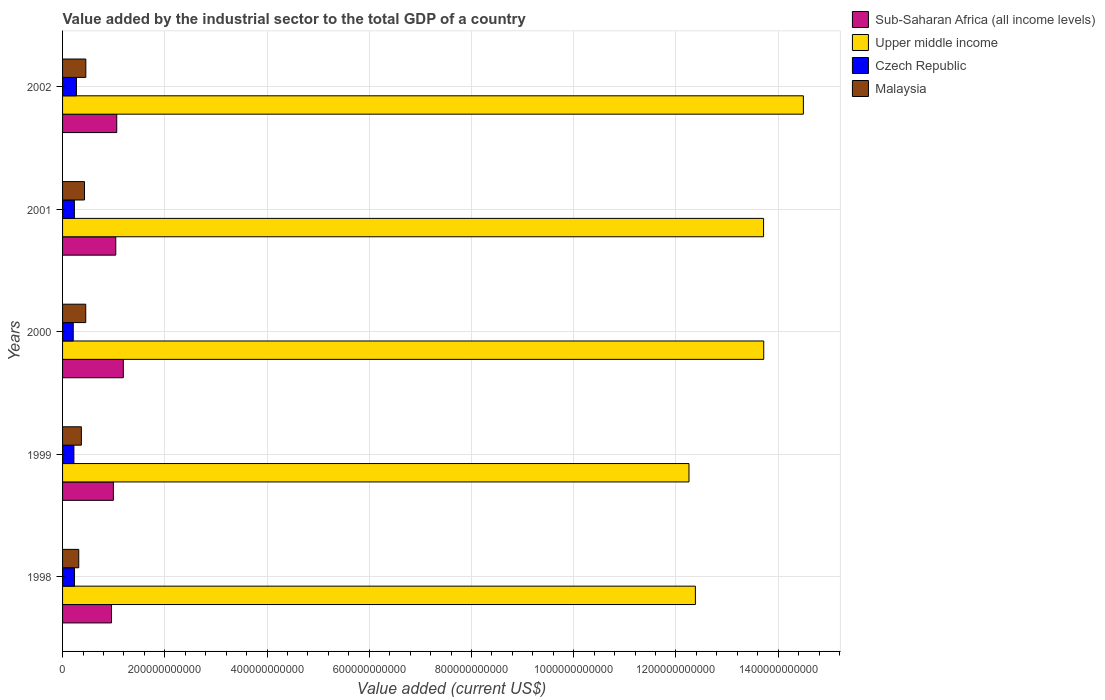Are the number of bars on each tick of the Y-axis equal?
Offer a terse response. Yes. How many bars are there on the 4th tick from the top?
Offer a very short reply. 4. How many bars are there on the 4th tick from the bottom?
Give a very brief answer. 4. What is the label of the 4th group of bars from the top?
Your answer should be very brief. 1999. What is the value added by the industrial sector to the total GDP in Czech Republic in 2002?
Keep it short and to the point. 2.72e+1. Across all years, what is the maximum value added by the industrial sector to the total GDP in Upper middle income?
Your response must be concise. 1.45e+12. Across all years, what is the minimum value added by the industrial sector to the total GDP in Czech Republic?
Your response must be concise. 2.09e+1. In which year was the value added by the industrial sector to the total GDP in Malaysia maximum?
Give a very brief answer. 2002. In which year was the value added by the industrial sector to the total GDP in Malaysia minimum?
Your response must be concise. 1998. What is the total value added by the industrial sector to the total GDP in Czech Republic in the graph?
Provide a short and direct response. 1.17e+11. What is the difference between the value added by the industrial sector to the total GDP in Czech Republic in 1998 and that in 2001?
Provide a short and direct response. 2.36e+08. What is the difference between the value added by the industrial sector to the total GDP in Upper middle income in 1999 and the value added by the industrial sector to the total GDP in Sub-Saharan Africa (all income levels) in 2002?
Give a very brief answer. 1.12e+12. What is the average value added by the industrial sector to the total GDP in Czech Republic per year?
Make the answer very short. 2.34e+1. In the year 2000, what is the difference between the value added by the industrial sector to the total GDP in Malaysia and value added by the industrial sector to the total GDP in Upper middle income?
Offer a terse response. -1.33e+12. What is the ratio of the value added by the industrial sector to the total GDP in Sub-Saharan Africa (all income levels) in 1998 to that in 2002?
Ensure brevity in your answer.  0.9. What is the difference between the highest and the second highest value added by the industrial sector to the total GDP in Upper middle income?
Provide a succinct answer. 7.75e+1. What is the difference between the highest and the lowest value added by the industrial sector to the total GDP in Malaysia?
Provide a short and direct response. 1.38e+1. Is it the case that in every year, the sum of the value added by the industrial sector to the total GDP in Upper middle income and value added by the industrial sector to the total GDP in Malaysia is greater than the sum of value added by the industrial sector to the total GDP in Sub-Saharan Africa (all income levels) and value added by the industrial sector to the total GDP in Czech Republic?
Offer a very short reply. No. What does the 1st bar from the top in 2002 represents?
Your answer should be compact. Malaysia. What does the 1st bar from the bottom in 1999 represents?
Give a very brief answer. Sub-Saharan Africa (all income levels). How many bars are there?
Your answer should be compact. 20. What is the difference between two consecutive major ticks on the X-axis?
Keep it short and to the point. 2.00e+11. Are the values on the major ticks of X-axis written in scientific E-notation?
Your response must be concise. No. Does the graph contain any zero values?
Ensure brevity in your answer.  No. Does the graph contain grids?
Your answer should be compact. Yes. Where does the legend appear in the graph?
Give a very brief answer. Top right. How many legend labels are there?
Give a very brief answer. 4. How are the legend labels stacked?
Provide a short and direct response. Vertical. What is the title of the graph?
Give a very brief answer. Value added by the industrial sector to the total GDP of a country. What is the label or title of the X-axis?
Keep it short and to the point. Value added (current US$). What is the label or title of the Y-axis?
Provide a short and direct response. Years. What is the Value added (current US$) in Sub-Saharan Africa (all income levels) in 1998?
Provide a succinct answer. 9.58e+1. What is the Value added (current US$) of Upper middle income in 1998?
Your answer should be very brief. 1.24e+12. What is the Value added (current US$) of Czech Republic in 1998?
Provide a succinct answer. 2.34e+1. What is the Value added (current US$) of Malaysia in 1998?
Ensure brevity in your answer.  3.17e+1. What is the Value added (current US$) of Sub-Saharan Africa (all income levels) in 1999?
Offer a very short reply. 9.94e+1. What is the Value added (current US$) of Upper middle income in 1999?
Offer a very short reply. 1.23e+12. What is the Value added (current US$) in Czech Republic in 1999?
Offer a very short reply. 2.21e+1. What is the Value added (current US$) in Malaysia in 1999?
Make the answer very short. 3.68e+1. What is the Value added (current US$) in Sub-Saharan Africa (all income levels) in 2000?
Provide a succinct answer. 1.19e+11. What is the Value added (current US$) of Upper middle income in 2000?
Your answer should be compact. 1.37e+12. What is the Value added (current US$) in Czech Republic in 2000?
Your response must be concise. 2.09e+1. What is the Value added (current US$) of Malaysia in 2000?
Your answer should be compact. 4.53e+1. What is the Value added (current US$) of Sub-Saharan Africa (all income levels) in 2001?
Offer a terse response. 1.04e+11. What is the Value added (current US$) of Upper middle income in 2001?
Your answer should be compact. 1.37e+12. What is the Value added (current US$) of Czech Republic in 2001?
Provide a short and direct response. 2.31e+1. What is the Value added (current US$) in Malaysia in 2001?
Provide a succinct answer. 4.29e+1. What is the Value added (current US$) of Sub-Saharan Africa (all income levels) in 2002?
Provide a succinct answer. 1.06e+11. What is the Value added (current US$) of Upper middle income in 2002?
Offer a very short reply. 1.45e+12. What is the Value added (current US$) in Czech Republic in 2002?
Give a very brief answer. 2.72e+1. What is the Value added (current US$) of Malaysia in 2002?
Offer a terse response. 4.55e+1. Across all years, what is the maximum Value added (current US$) of Sub-Saharan Africa (all income levels)?
Your answer should be compact. 1.19e+11. Across all years, what is the maximum Value added (current US$) in Upper middle income?
Your answer should be compact. 1.45e+12. Across all years, what is the maximum Value added (current US$) of Czech Republic?
Your answer should be compact. 2.72e+1. Across all years, what is the maximum Value added (current US$) of Malaysia?
Offer a very short reply. 4.55e+1. Across all years, what is the minimum Value added (current US$) of Sub-Saharan Africa (all income levels)?
Your response must be concise. 9.58e+1. Across all years, what is the minimum Value added (current US$) in Upper middle income?
Offer a terse response. 1.23e+12. Across all years, what is the minimum Value added (current US$) of Czech Republic?
Your answer should be very brief. 2.09e+1. Across all years, what is the minimum Value added (current US$) of Malaysia?
Offer a terse response. 3.17e+1. What is the total Value added (current US$) of Sub-Saharan Africa (all income levels) in the graph?
Make the answer very short. 5.24e+11. What is the total Value added (current US$) of Upper middle income in the graph?
Keep it short and to the point. 6.66e+12. What is the total Value added (current US$) of Czech Republic in the graph?
Your answer should be compact. 1.17e+11. What is the total Value added (current US$) in Malaysia in the graph?
Provide a succinct answer. 2.02e+11. What is the difference between the Value added (current US$) of Sub-Saharan Africa (all income levels) in 1998 and that in 1999?
Your answer should be very brief. -3.67e+09. What is the difference between the Value added (current US$) in Upper middle income in 1998 and that in 1999?
Your response must be concise. 1.25e+1. What is the difference between the Value added (current US$) of Czech Republic in 1998 and that in 1999?
Keep it short and to the point. 1.23e+09. What is the difference between the Value added (current US$) in Malaysia in 1998 and that in 1999?
Make the answer very short. -5.11e+09. What is the difference between the Value added (current US$) in Sub-Saharan Africa (all income levels) in 1998 and that in 2000?
Your answer should be very brief. -2.31e+1. What is the difference between the Value added (current US$) in Upper middle income in 1998 and that in 2000?
Your response must be concise. -1.34e+11. What is the difference between the Value added (current US$) of Czech Republic in 1998 and that in 2000?
Keep it short and to the point. 2.49e+09. What is the difference between the Value added (current US$) of Malaysia in 1998 and that in 2000?
Ensure brevity in your answer.  -1.37e+1. What is the difference between the Value added (current US$) in Sub-Saharan Africa (all income levels) in 1998 and that in 2001?
Make the answer very short. -8.33e+09. What is the difference between the Value added (current US$) in Upper middle income in 1998 and that in 2001?
Provide a succinct answer. -1.33e+11. What is the difference between the Value added (current US$) in Czech Republic in 1998 and that in 2001?
Your answer should be compact. 2.36e+08. What is the difference between the Value added (current US$) in Malaysia in 1998 and that in 2001?
Keep it short and to the point. -1.12e+1. What is the difference between the Value added (current US$) of Sub-Saharan Africa (all income levels) in 1998 and that in 2002?
Your answer should be compact. -1.02e+1. What is the difference between the Value added (current US$) of Upper middle income in 1998 and that in 2002?
Offer a terse response. -2.11e+11. What is the difference between the Value added (current US$) in Czech Republic in 1998 and that in 2002?
Ensure brevity in your answer.  -3.86e+09. What is the difference between the Value added (current US$) of Malaysia in 1998 and that in 2002?
Your answer should be very brief. -1.38e+1. What is the difference between the Value added (current US$) in Sub-Saharan Africa (all income levels) in 1999 and that in 2000?
Make the answer very short. -1.94e+1. What is the difference between the Value added (current US$) of Upper middle income in 1999 and that in 2000?
Offer a very short reply. -1.46e+11. What is the difference between the Value added (current US$) in Czech Republic in 1999 and that in 2000?
Your answer should be compact. 1.26e+09. What is the difference between the Value added (current US$) in Malaysia in 1999 and that in 2000?
Provide a short and direct response. -8.55e+09. What is the difference between the Value added (current US$) of Sub-Saharan Africa (all income levels) in 1999 and that in 2001?
Keep it short and to the point. -4.66e+09. What is the difference between the Value added (current US$) of Upper middle income in 1999 and that in 2001?
Your answer should be compact. -1.46e+11. What is the difference between the Value added (current US$) of Czech Republic in 1999 and that in 2001?
Offer a terse response. -9.94e+08. What is the difference between the Value added (current US$) in Malaysia in 1999 and that in 2001?
Ensure brevity in your answer.  -6.10e+09. What is the difference between the Value added (current US$) in Sub-Saharan Africa (all income levels) in 1999 and that in 2002?
Ensure brevity in your answer.  -6.55e+09. What is the difference between the Value added (current US$) of Upper middle income in 1999 and that in 2002?
Provide a short and direct response. -2.24e+11. What is the difference between the Value added (current US$) of Czech Republic in 1999 and that in 2002?
Provide a short and direct response. -5.09e+09. What is the difference between the Value added (current US$) in Malaysia in 1999 and that in 2002?
Make the answer very short. -8.72e+09. What is the difference between the Value added (current US$) in Sub-Saharan Africa (all income levels) in 2000 and that in 2001?
Offer a very short reply. 1.48e+1. What is the difference between the Value added (current US$) in Upper middle income in 2000 and that in 2001?
Give a very brief answer. 3.16e+08. What is the difference between the Value added (current US$) in Czech Republic in 2000 and that in 2001?
Provide a succinct answer. -2.26e+09. What is the difference between the Value added (current US$) of Malaysia in 2000 and that in 2001?
Ensure brevity in your answer.  2.45e+09. What is the difference between the Value added (current US$) of Sub-Saharan Africa (all income levels) in 2000 and that in 2002?
Offer a terse response. 1.29e+1. What is the difference between the Value added (current US$) in Upper middle income in 2000 and that in 2002?
Make the answer very short. -7.75e+1. What is the difference between the Value added (current US$) in Czech Republic in 2000 and that in 2002?
Your answer should be very brief. -6.35e+09. What is the difference between the Value added (current US$) of Malaysia in 2000 and that in 2002?
Your answer should be compact. -1.78e+08. What is the difference between the Value added (current US$) of Sub-Saharan Africa (all income levels) in 2001 and that in 2002?
Your response must be concise. -1.89e+09. What is the difference between the Value added (current US$) of Upper middle income in 2001 and that in 2002?
Your response must be concise. -7.79e+1. What is the difference between the Value added (current US$) in Czech Republic in 2001 and that in 2002?
Make the answer very short. -4.10e+09. What is the difference between the Value added (current US$) of Malaysia in 2001 and that in 2002?
Your answer should be very brief. -2.63e+09. What is the difference between the Value added (current US$) of Sub-Saharan Africa (all income levels) in 1998 and the Value added (current US$) of Upper middle income in 1999?
Your answer should be very brief. -1.13e+12. What is the difference between the Value added (current US$) of Sub-Saharan Africa (all income levels) in 1998 and the Value added (current US$) of Czech Republic in 1999?
Provide a succinct answer. 7.36e+1. What is the difference between the Value added (current US$) in Sub-Saharan Africa (all income levels) in 1998 and the Value added (current US$) in Malaysia in 1999?
Offer a terse response. 5.90e+1. What is the difference between the Value added (current US$) in Upper middle income in 1998 and the Value added (current US$) in Czech Republic in 1999?
Give a very brief answer. 1.22e+12. What is the difference between the Value added (current US$) of Upper middle income in 1998 and the Value added (current US$) of Malaysia in 1999?
Provide a succinct answer. 1.20e+12. What is the difference between the Value added (current US$) in Czech Republic in 1998 and the Value added (current US$) in Malaysia in 1999?
Your response must be concise. -1.34e+1. What is the difference between the Value added (current US$) of Sub-Saharan Africa (all income levels) in 1998 and the Value added (current US$) of Upper middle income in 2000?
Your answer should be very brief. -1.28e+12. What is the difference between the Value added (current US$) in Sub-Saharan Africa (all income levels) in 1998 and the Value added (current US$) in Czech Republic in 2000?
Your answer should be compact. 7.49e+1. What is the difference between the Value added (current US$) in Sub-Saharan Africa (all income levels) in 1998 and the Value added (current US$) in Malaysia in 2000?
Make the answer very short. 5.04e+1. What is the difference between the Value added (current US$) in Upper middle income in 1998 and the Value added (current US$) in Czech Republic in 2000?
Provide a succinct answer. 1.22e+12. What is the difference between the Value added (current US$) of Upper middle income in 1998 and the Value added (current US$) of Malaysia in 2000?
Keep it short and to the point. 1.19e+12. What is the difference between the Value added (current US$) of Czech Republic in 1998 and the Value added (current US$) of Malaysia in 2000?
Make the answer very short. -2.19e+1. What is the difference between the Value added (current US$) of Sub-Saharan Africa (all income levels) in 1998 and the Value added (current US$) of Upper middle income in 2001?
Keep it short and to the point. -1.28e+12. What is the difference between the Value added (current US$) of Sub-Saharan Africa (all income levels) in 1998 and the Value added (current US$) of Czech Republic in 2001?
Make the answer very short. 7.26e+1. What is the difference between the Value added (current US$) of Sub-Saharan Africa (all income levels) in 1998 and the Value added (current US$) of Malaysia in 2001?
Provide a short and direct response. 5.29e+1. What is the difference between the Value added (current US$) in Upper middle income in 1998 and the Value added (current US$) in Czech Republic in 2001?
Ensure brevity in your answer.  1.21e+12. What is the difference between the Value added (current US$) in Upper middle income in 1998 and the Value added (current US$) in Malaysia in 2001?
Your answer should be compact. 1.20e+12. What is the difference between the Value added (current US$) in Czech Republic in 1998 and the Value added (current US$) in Malaysia in 2001?
Your response must be concise. -1.95e+1. What is the difference between the Value added (current US$) in Sub-Saharan Africa (all income levels) in 1998 and the Value added (current US$) in Upper middle income in 2002?
Offer a very short reply. -1.35e+12. What is the difference between the Value added (current US$) of Sub-Saharan Africa (all income levels) in 1998 and the Value added (current US$) of Czech Republic in 2002?
Your answer should be very brief. 6.85e+1. What is the difference between the Value added (current US$) in Sub-Saharan Africa (all income levels) in 1998 and the Value added (current US$) in Malaysia in 2002?
Your answer should be very brief. 5.03e+1. What is the difference between the Value added (current US$) in Upper middle income in 1998 and the Value added (current US$) in Czech Republic in 2002?
Your response must be concise. 1.21e+12. What is the difference between the Value added (current US$) of Upper middle income in 1998 and the Value added (current US$) of Malaysia in 2002?
Keep it short and to the point. 1.19e+12. What is the difference between the Value added (current US$) of Czech Republic in 1998 and the Value added (current US$) of Malaysia in 2002?
Your answer should be compact. -2.21e+1. What is the difference between the Value added (current US$) in Sub-Saharan Africa (all income levels) in 1999 and the Value added (current US$) in Upper middle income in 2000?
Your answer should be very brief. -1.27e+12. What is the difference between the Value added (current US$) in Sub-Saharan Africa (all income levels) in 1999 and the Value added (current US$) in Czech Republic in 2000?
Offer a very short reply. 7.85e+1. What is the difference between the Value added (current US$) in Sub-Saharan Africa (all income levels) in 1999 and the Value added (current US$) in Malaysia in 2000?
Ensure brevity in your answer.  5.41e+1. What is the difference between the Value added (current US$) of Upper middle income in 1999 and the Value added (current US$) of Czech Republic in 2000?
Your answer should be very brief. 1.20e+12. What is the difference between the Value added (current US$) of Upper middle income in 1999 and the Value added (current US$) of Malaysia in 2000?
Your response must be concise. 1.18e+12. What is the difference between the Value added (current US$) in Czech Republic in 1999 and the Value added (current US$) in Malaysia in 2000?
Give a very brief answer. -2.32e+1. What is the difference between the Value added (current US$) of Sub-Saharan Africa (all income levels) in 1999 and the Value added (current US$) of Upper middle income in 2001?
Your response must be concise. -1.27e+12. What is the difference between the Value added (current US$) of Sub-Saharan Africa (all income levels) in 1999 and the Value added (current US$) of Czech Republic in 2001?
Your answer should be very brief. 7.63e+1. What is the difference between the Value added (current US$) of Sub-Saharan Africa (all income levels) in 1999 and the Value added (current US$) of Malaysia in 2001?
Keep it short and to the point. 5.66e+1. What is the difference between the Value added (current US$) of Upper middle income in 1999 and the Value added (current US$) of Czech Republic in 2001?
Your response must be concise. 1.20e+12. What is the difference between the Value added (current US$) of Upper middle income in 1999 and the Value added (current US$) of Malaysia in 2001?
Your answer should be compact. 1.18e+12. What is the difference between the Value added (current US$) of Czech Republic in 1999 and the Value added (current US$) of Malaysia in 2001?
Your answer should be very brief. -2.07e+1. What is the difference between the Value added (current US$) of Sub-Saharan Africa (all income levels) in 1999 and the Value added (current US$) of Upper middle income in 2002?
Give a very brief answer. -1.35e+12. What is the difference between the Value added (current US$) in Sub-Saharan Africa (all income levels) in 1999 and the Value added (current US$) in Czech Republic in 2002?
Provide a succinct answer. 7.22e+1. What is the difference between the Value added (current US$) of Sub-Saharan Africa (all income levels) in 1999 and the Value added (current US$) of Malaysia in 2002?
Keep it short and to the point. 5.39e+1. What is the difference between the Value added (current US$) in Upper middle income in 1999 and the Value added (current US$) in Czech Republic in 2002?
Provide a succinct answer. 1.20e+12. What is the difference between the Value added (current US$) in Upper middle income in 1999 and the Value added (current US$) in Malaysia in 2002?
Make the answer very short. 1.18e+12. What is the difference between the Value added (current US$) of Czech Republic in 1999 and the Value added (current US$) of Malaysia in 2002?
Provide a succinct answer. -2.34e+1. What is the difference between the Value added (current US$) in Sub-Saharan Africa (all income levels) in 2000 and the Value added (current US$) in Upper middle income in 2001?
Offer a very short reply. -1.25e+12. What is the difference between the Value added (current US$) of Sub-Saharan Africa (all income levels) in 2000 and the Value added (current US$) of Czech Republic in 2001?
Provide a succinct answer. 9.57e+1. What is the difference between the Value added (current US$) of Sub-Saharan Africa (all income levels) in 2000 and the Value added (current US$) of Malaysia in 2001?
Offer a terse response. 7.60e+1. What is the difference between the Value added (current US$) of Upper middle income in 2000 and the Value added (current US$) of Czech Republic in 2001?
Give a very brief answer. 1.35e+12. What is the difference between the Value added (current US$) in Upper middle income in 2000 and the Value added (current US$) in Malaysia in 2001?
Your answer should be very brief. 1.33e+12. What is the difference between the Value added (current US$) in Czech Republic in 2000 and the Value added (current US$) in Malaysia in 2001?
Offer a terse response. -2.20e+1. What is the difference between the Value added (current US$) in Sub-Saharan Africa (all income levels) in 2000 and the Value added (current US$) in Upper middle income in 2002?
Keep it short and to the point. -1.33e+12. What is the difference between the Value added (current US$) of Sub-Saharan Africa (all income levels) in 2000 and the Value added (current US$) of Czech Republic in 2002?
Your response must be concise. 9.16e+1. What is the difference between the Value added (current US$) in Sub-Saharan Africa (all income levels) in 2000 and the Value added (current US$) in Malaysia in 2002?
Your answer should be very brief. 7.34e+1. What is the difference between the Value added (current US$) in Upper middle income in 2000 and the Value added (current US$) in Czech Republic in 2002?
Your response must be concise. 1.34e+12. What is the difference between the Value added (current US$) of Upper middle income in 2000 and the Value added (current US$) of Malaysia in 2002?
Provide a short and direct response. 1.33e+12. What is the difference between the Value added (current US$) of Czech Republic in 2000 and the Value added (current US$) of Malaysia in 2002?
Your answer should be compact. -2.46e+1. What is the difference between the Value added (current US$) of Sub-Saharan Africa (all income levels) in 2001 and the Value added (current US$) of Upper middle income in 2002?
Make the answer very short. -1.35e+12. What is the difference between the Value added (current US$) in Sub-Saharan Africa (all income levels) in 2001 and the Value added (current US$) in Czech Republic in 2002?
Offer a very short reply. 7.69e+1. What is the difference between the Value added (current US$) in Sub-Saharan Africa (all income levels) in 2001 and the Value added (current US$) in Malaysia in 2002?
Your answer should be compact. 5.86e+1. What is the difference between the Value added (current US$) in Upper middle income in 2001 and the Value added (current US$) in Czech Republic in 2002?
Offer a terse response. 1.34e+12. What is the difference between the Value added (current US$) of Upper middle income in 2001 and the Value added (current US$) of Malaysia in 2002?
Offer a terse response. 1.33e+12. What is the difference between the Value added (current US$) of Czech Republic in 2001 and the Value added (current US$) of Malaysia in 2002?
Your answer should be compact. -2.24e+1. What is the average Value added (current US$) in Sub-Saharan Africa (all income levels) per year?
Ensure brevity in your answer.  1.05e+11. What is the average Value added (current US$) in Upper middle income per year?
Offer a terse response. 1.33e+12. What is the average Value added (current US$) of Czech Republic per year?
Give a very brief answer. 2.34e+1. What is the average Value added (current US$) in Malaysia per year?
Give a very brief answer. 4.04e+1. In the year 1998, what is the difference between the Value added (current US$) in Sub-Saharan Africa (all income levels) and Value added (current US$) in Upper middle income?
Your response must be concise. -1.14e+12. In the year 1998, what is the difference between the Value added (current US$) in Sub-Saharan Africa (all income levels) and Value added (current US$) in Czech Republic?
Keep it short and to the point. 7.24e+1. In the year 1998, what is the difference between the Value added (current US$) of Sub-Saharan Africa (all income levels) and Value added (current US$) of Malaysia?
Make the answer very short. 6.41e+1. In the year 1998, what is the difference between the Value added (current US$) of Upper middle income and Value added (current US$) of Czech Republic?
Offer a terse response. 1.21e+12. In the year 1998, what is the difference between the Value added (current US$) of Upper middle income and Value added (current US$) of Malaysia?
Make the answer very short. 1.21e+12. In the year 1998, what is the difference between the Value added (current US$) in Czech Republic and Value added (current US$) in Malaysia?
Keep it short and to the point. -8.29e+09. In the year 1999, what is the difference between the Value added (current US$) in Sub-Saharan Africa (all income levels) and Value added (current US$) in Upper middle income?
Your answer should be compact. -1.13e+12. In the year 1999, what is the difference between the Value added (current US$) of Sub-Saharan Africa (all income levels) and Value added (current US$) of Czech Republic?
Make the answer very short. 7.73e+1. In the year 1999, what is the difference between the Value added (current US$) in Sub-Saharan Africa (all income levels) and Value added (current US$) in Malaysia?
Your answer should be very brief. 6.27e+1. In the year 1999, what is the difference between the Value added (current US$) in Upper middle income and Value added (current US$) in Czech Republic?
Your answer should be very brief. 1.20e+12. In the year 1999, what is the difference between the Value added (current US$) in Upper middle income and Value added (current US$) in Malaysia?
Give a very brief answer. 1.19e+12. In the year 1999, what is the difference between the Value added (current US$) of Czech Republic and Value added (current US$) of Malaysia?
Keep it short and to the point. -1.46e+1. In the year 2000, what is the difference between the Value added (current US$) of Sub-Saharan Africa (all income levels) and Value added (current US$) of Upper middle income?
Offer a very short reply. -1.25e+12. In the year 2000, what is the difference between the Value added (current US$) of Sub-Saharan Africa (all income levels) and Value added (current US$) of Czech Republic?
Give a very brief answer. 9.80e+1. In the year 2000, what is the difference between the Value added (current US$) of Sub-Saharan Africa (all income levels) and Value added (current US$) of Malaysia?
Your answer should be very brief. 7.35e+1. In the year 2000, what is the difference between the Value added (current US$) of Upper middle income and Value added (current US$) of Czech Republic?
Keep it short and to the point. 1.35e+12. In the year 2000, what is the difference between the Value added (current US$) of Upper middle income and Value added (current US$) of Malaysia?
Offer a very short reply. 1.33e+12. In the year 2000, what is the difference between the Value added (current US$) in Czech Republic and Value added (current US$) in Malaysia?
Your answer should be compact. -2.44e+1. In the year 2001, what is the difference between the Value added (current US$) in Sub-Saharan Africa (all income levels) and Value added (current US$) in Upper middle income?
Offer a terse response. -1.27e+12. In the year 2001, what is the difference between the Value added (current US$) in Sub-Saharan Africa (all income levels) and Value added (current US$) in Czech Republic?
Give a very brief answer. 8.09e+1. In the year 2001, what is the difference between the Value added (current US$) of Sub-Saharan Africa (all income levels) and Value added (current US$) of Malaysia?
Offer a terse response. 6.12e+1. In the year 2001, what is the difference between the Value added (current US$) of Upper middle income and Value added (current US$) of Czech Republic?
Provide a succinct answer. 1.35e+12. In the year 2001, what is the difference between the Value added (current US$) in Upper middle income and Value added (current US$) in Malaysia?
Your response must be concise. 1.33e+12. In the year 2001, what is the difference between the Value added (current US$) in Czech Republic and Value added (current US$) in Malaysia?
Your response must be concise. -1.97e+1. In the year 2002, what is the difference between the Value added (current US$) of Sub-Saharan Africa (all income levels) and Value added (current US$) of Upper middle income?
Ensure brevity in your answer.  -1.34e+12. In the year 2002, what is the difference between the Value added (current US$) of Sub-Saharan Africa (all income levels) and Value added (current US$) of Czech Republic?
Make the answer very short. 7.87e+1. In the year 2002, what is the difference between the Value added (current US$) in Sub-Saharan Africa (all income levels) and Value added (current US$) in Malaysia?
Offer a terse response. 6.05e+1. In the year 2002, what is the difference between the Value added (current US$) in Upper middle income and Value added (current US$) in Czech Republic?
Ensure brevity in your answer.  1.42e+12. In the year 2002, what is the difference between the Value added (current US$) in Upper middle income and Value added (current US$) in Malaysia?
Provide a succinct answer. 1.40e+12. In the year 2002, what is the difference between the Value added (current US$) in Czech Republic and Value added (current US$) in Malaysia?
Offer a very short reply. -1.83e+1. What is the ratio of the Value added (current US$) of Sub-Saharan Africa (all income levels) in 1998 to that in 1999?
Ensure brevity in your answer.  0.96. What is the ratio of the Value added (current US$) of Upper middle income in 1998 to that in 1999?
Offer a very short reply. 1.01. What is the ratio of the Value added (current US$) in Czech Republic in 1998 to that in 1999?
Your answer should be compact. 1.06. What is the ratio of the Value added (current US$) in Malaysia in 1998 to that in 1999?
Make the answer very short. 0.86. What is the ratio of the Value added (current US$) in Sub-Saharan Africa (all income levels) in 1998 to that in 2000?
Keep it short and to the point. 0.81. What is the ratio of the Value added (current US$) of Upper middle income in 1998 to that in 2000?
Your answer should be very brief. 0.9. What is the ratio of the Value added (current US$) in Czech Republic in 1998 to that in 2000?
Make the answer very short. 1.12. What is the ratio of the Value added (current US$) in Malaysia in 1998 to that in 2000?
Provide a short and direct response. 0.7. What is the ratio of the Value added (current US$) in Sub-Saharan Africa (all income levels) in 1998 to that in 2001?
Keep it short and to the point. 0.92. What is the ratio of the Value added (current US$) in Upper middle income in 1998 to that in 2001?
Provide a succinct answer. 0.9. What is the ratio of the Value added (current US$) of Czech Republic in 1998 to that in 2001?
Provide a succinct answer. 1.01. What is the ratio of the Value added (current US$) in Malaysia in 1998 to that in 2001?
Your response must be concise. 0.74. What is the ratio of the Value added (current US$) of Sub-Saharan Africa (all income levels) in 1998 to that in 2002?
Your answer should be very brief. 0.9. What is the ratio of the Value added (current US$) of Upper middle income in 1998 to that in 2002?
Make the answer very short. 0.85. What is the ratio of the Value added (current US$) of Czech Republic in 1998 to that in 2002?
Keep it short and to the point. 0.86. What is the ratio of the Value added (current US$) in Malaysia in 1998 to that in 2002?
Your answer should be compact. 0.7. What is the ratio of the Value added (current US$) of Sub-Saharan Africa (all income levels) in 1999 to that in 2000?
Ensure brevity in your answer.  0.84. What is the ratio of the Value added (current US$) of Upper middle income in 1999 to that in 2000?
Provide a succinct answer. 0.89. What is the ratio of the Value added (current US$) of Czech Republic in 1999 to that in 2000?
Provide a short and direct response. 1.06. What is the ratio of the Value added (current US$) in Malaysia in 1999 to that in 2000?
Your answer should be compact. 0.81. What is the ratio of the Value added (current US$) of Sub-Saharan Africa (all income levels) in 1999 to that in 2001?
Your answer should be compact. 0.96. What is the ratio of the Value added (current US$) in Upper middle income in 1999 to that in 2001?
Your answer should be compact. 0.89. What is the ratio of the Value added (current US$) of Czech Republic in 1999 to that in 2001?
Give a very brief answer. 0.96. What is the ratio of the Value added (current US$) of Malaysia in 1999 to that in 2001?
Keep it short and to the point. 0.86. What is the ratio of the Value added (current US$) of Sub-Saharan Africa (all income levels) in 1999 to that in 2002?
Give a very brief answer. 0.94. What is the ratio of the Value added (current US$) in Upper middle income in 1999 to that in 2002?
Give a very brief answer. 0.85. What is the ratio of the Value added (current US$) in Czech Republic in 1999 to that in 2002?
Your answer should be very brief. 0.81. What is the ratio of the Value added (current US$) in Malaysia in 1999 to that in 2002?
Keep it short and to the point. 0.81. What is the ratio of the Value added (current US$) of Sub-Saharan Africa (all income levels) in 2000 to that in 2001?
Keep it short and to the point. 1.14. What is the ratio of the Value added (current US$) of Upper middle income in 2000 to that in 2001?
Your response must be concise. 1. What is the ratio of the Value added (current US$) of Czech Republic in 2000 to that in 2001?
Offer a very short reply. 0.9. What is the ratio of the Value added (current US$) of Malaysia in 2000 to that in 2001?
Keep it short and to the point. 1.06. What is the ratio of the Value added (current US$) of Sub-Saharan Africa (all income levels) in 2000 to that in 2002?
Provide a short and direct response. 1.12. What is the ratio of the Value added (current US$) of Upper middle income in 2000 to that in 2002?
Provide a succinct answer. 0.95. What is the ratio of the Value added (current US$) of Czech Republic in 2000 to that in 2002?
Ensure brevity in your answer.  0.77. What is the ratio of the Value added (current US$) of Sub-Saharan Africa (all income levels) in 2001 to that in 2002?
Offer a terse response. 0.98. What is the ratio of the Value added (current US$) in Upper middle income in 2001 to that in 2002?
Your answer should be very brief. 0.95. What is the ratio of the Value added (current US$) in Czech Republic in 2001 to that in 2002?
Your response must be concise. 0.85. What is the ratio of the Value added (current US$) of Malaysia in 2001 to that in 2002?
Offer a very short reply. 0.94. What is the difference between the highest and the second highest Value added (current US$) of Sub-Saharan Africa (all income levels)?
Provide a short and direct response. 1.29e+1. What is the difference between the highest and the second highest Value added (current US$) of Upper middle income?
Make the answer very short. 7.75e+1. What is the difference between the highest and the second highest Value added (current US$) of Czech Republic?
Your answer should be compact. 3.86e+09. What is the difference between the highest and the second highest Value added (current US$) in Malaysia?
Ensure brevity in your answer.  1.78e+08. What is the difference between the highest and the lowest Value added (current US$) of Sub-Saharan Africa (all income levels)?
Your answer should be compact. 2.31e+1. What is the difference between the highest and the lowest Value added (current US$) of Upper middle income?
Provide a short and direct response. 2.24e+11. What is the difference between the highest and the lowest Value added (current US$) in Czech Republic?
Offer a very short reply. 6.35e+09. What is the difference between the highest and the lowest Value added (current US$) of Malaysia?
Your answer should be very brief. 1.38e+1. 